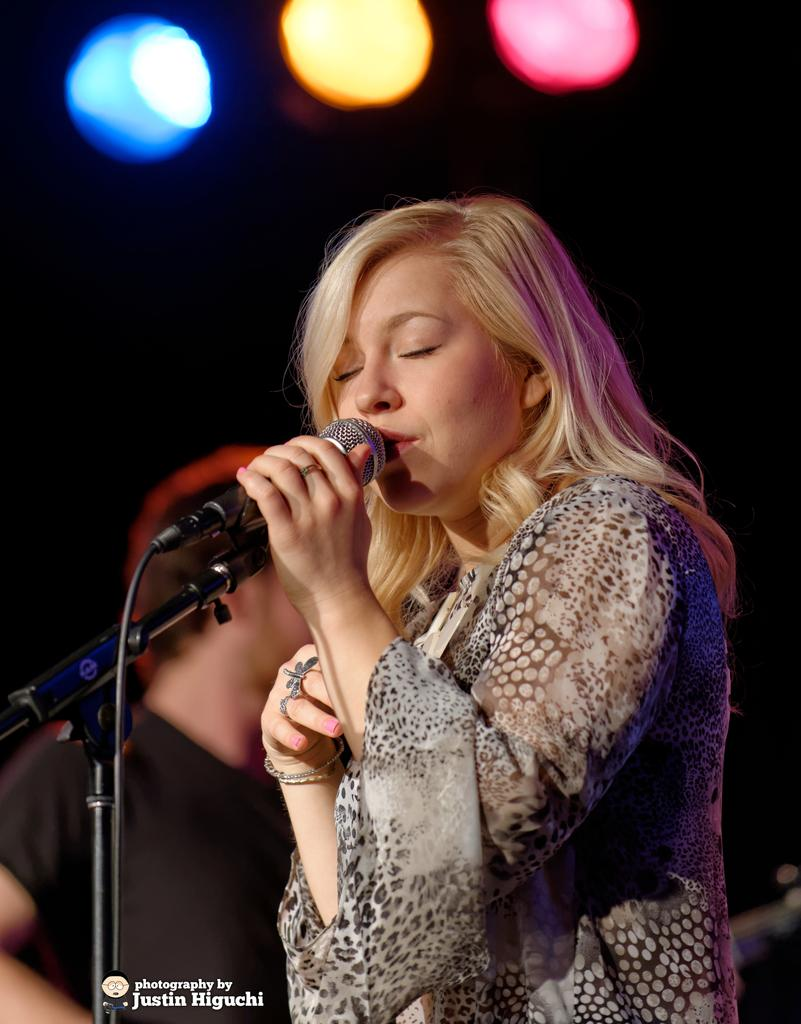Who is the main subject in the image? There is a woman in the image. What is the woman doing in the image? The woman is standing in the image. What object is in front of the woman? There is a microphone with a stand in front of the woman. What type of rifle is the woman holding in the image? There is no rifle present in the image; the woman is standing in front of a microphone with a stand. 